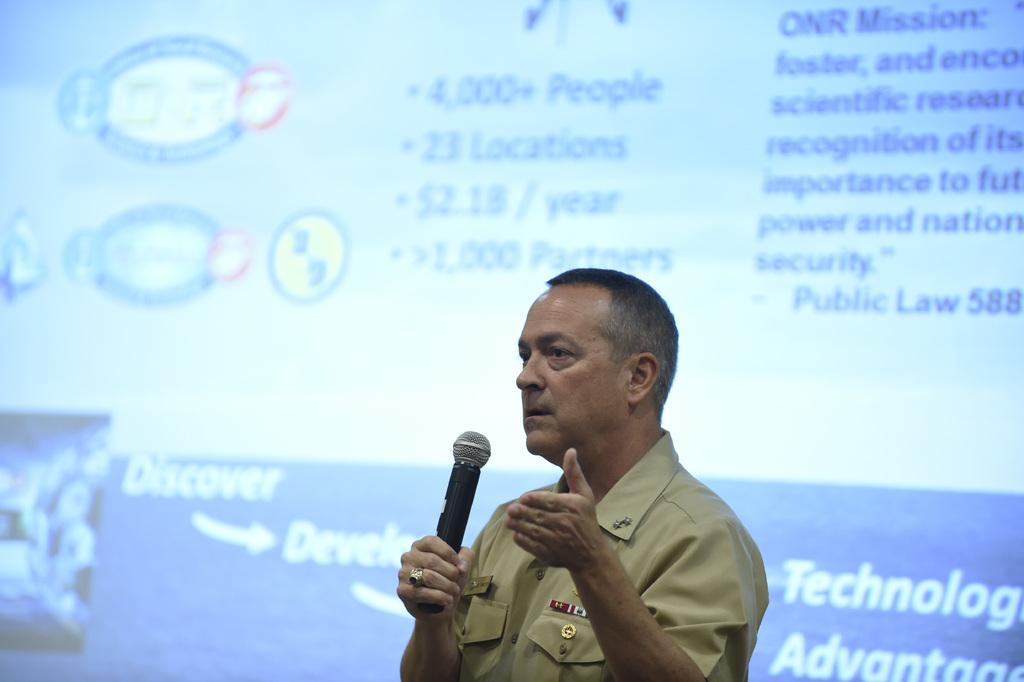Who is the main subject in the image? There is a person in the image. What is the person holding in the image? The person is holding a microphone. What is the person doing in the image? The person is speaking. What can be seen behind the person in the image? There is a screen behind the person. Can you see any lizards on the screen behind the person? There is no mention of lizards in the image, and the screen's content is not described in the provided facts. 